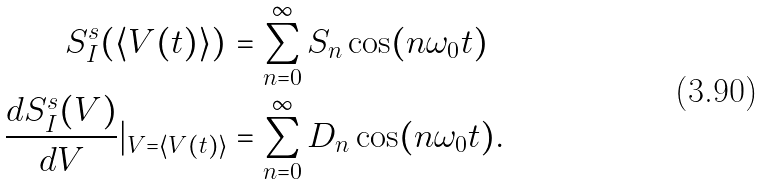Convert formula to latex. <formula><loc_0><loc_0><loc_500><loc_500>S _ { I } ^ { s } ( \langle V ( t ) \rangle ) & = \sum _ { n = 0 } ^ { \infty } S _ { n } \cos ( n \omega _ { 0 } t ) \\ \frac { d S _ { I } ^ { s } ( V ) } { d V } | _ { V = \langle V ( t ) \rangle } & = \sum _ { n = 0 } ^ { \infty } D _ { n } \cos ( n \omega _ { 0 } t ) .</formula> 